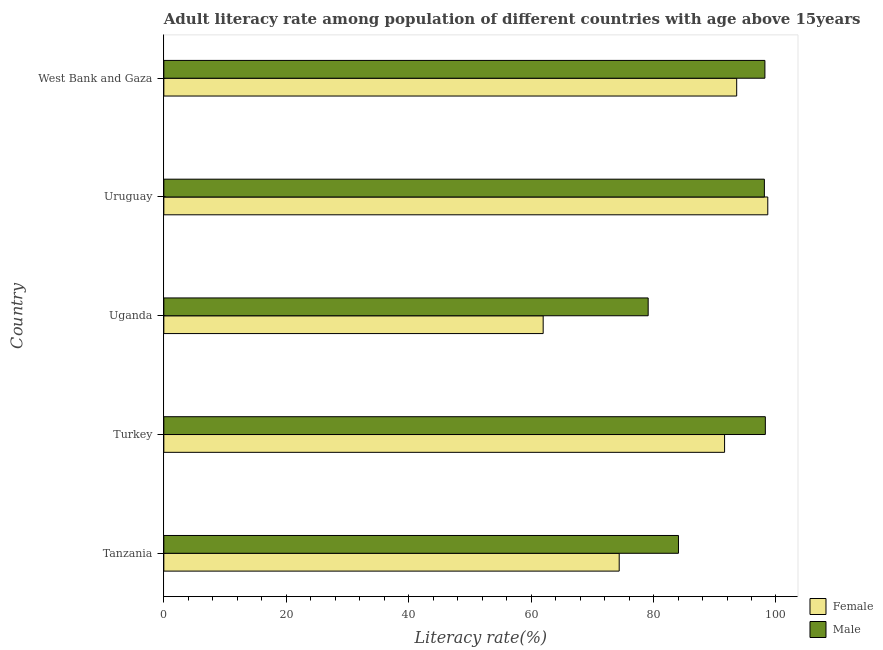How many different coloured bars are there?
Provide a short and direct response. 2. Are the number of bars per tick equal to the number of legend labels?
Provide a short and direct response. Yes. Are the number of bars on each tick of the Y-axis equal?
Offer a very short reply. Yes. What is the label of the 3rd group of bars from the top?
Your answer should be very brief. Uganda. In how many cases, is the number of bars for a given country not equal to the number of legend labels?
Keep it short and to the point. 0. What is the male adult literacy rate in Turkey?
Your answer should be very brief. 98.26. Across all countries, what is the maximum female adult literacy rate?
Provide a short and direct response. 98.66. Across all countries, what is the minimum male adult literacy rate?
Provide a short and direct response. 79.12. In which country was the male adult literacy rate minimum?
Give a very brief answer. Uganda. What is the total female adult literacy rate in the graph?
Your answer should be compact. 420.2. What is the difference between the male adult literacy rate in Tanzania and that in Uganda?
Your answer should be compact. 4.95. What is the difference between the female adult literacy rate in Turkey and the male adult literacy rate in Uruguay?
Give a very brief answer. -6.5. What is the average male adult literacy rate per country?
Make the answer very short. 91.55. What is the difference between the female adult literacy rate and male adult literacy rate in Uganda?
Your response must be concise. -17.15. In how many countries, is the male adult literacy rate greater than 8 %?
Your answer should be very brief. 5. What is the ratio of the male adult literacy rate in Tanzania to that in Turkey?
Provide a short and direct response. 0.86. What is the difference between the highest and the second highest female adult literacy rate?
Give a very brief answer. 5.08. What is the difference between the highest and the lowest female adult literacy rate?
Ensure brevity in your answer.  36.69. In how many countries, is the male adult literacy rate greater than the average male adult literacy rate taken over all countries?
Offer a very short reply. 3. What does the 1st bar from the bottom in Uganda represents?
Give a very brief answer. Female. How many bars are there?
Ensure brevity in your answer.  10. Are all the bars in the graph horizontal?
Your response must be concise. Yes. How many countries are there in the graph?
Your answer should be compact. 5. What is the difference between two consecutive major ticks on the X-axis?
Your answer should be compact. 20. Are the values on the major ticks of X-axis written in scientific E-notation?
Ensure brevity in your answer.  No. Does the graph contain any zero values?
Your response must be concise. No. Does the graph contain grids?
Make the answer very short. No. How many legend labels are there?
Provide a short and direct response. 2. What is the title of the graph?
Offer a terse response. Adult literacy rate among population of different countries with age above 15years. Does "Investment in Transport" appear as one of the legend labels in the graph?
Provide a short and direct response. No. What is the label or title of the X-axis?
Offer a terse response. Literacy rate(%). What is the Literacy rate(%) of Female in Tanzania?
Ensure brevity in your answer.  74.39. What is the Literacy rate(%) in Male in Tanzania?
Provide a succinct answer. 84.07. What is the Literacy rate(%) of Female in Turkey?
Your response must be concise. 91.6. What is the Literacy rate(%) in Male in Turkey?
Offer a terse response. 98.26. What is the Literacy rate(%) in Female in Uganda?
Your answer should be very brief. 61.97. What is the Literacy rate(%) of Male in Uganda?
Keep it short and to the point. 79.12. What is the Literacy rate(%) of Female in Uruguay?
Your answer should be very brief. 98.66. What is the Literacy rate(%) of Male in Uruguay?
Give a very brief answer. 98.1. What is the Literacy rate(%) of Female in West Bank and Gaza?
Your answer should be compact. 93.58. What is the Literacy rate(%) in Male in West Bank and Gaza?
Offer a terse response. 98.19. Across all countries, what is the maximum Literacy rate(%) of Female?
Ensure brevity in your answer.  98.66. Across all countries, what is the maximum Literacy rate(%) in Male?
Give a very brief answer. 98.26. Across all countries, what is the minimum Literacy rate(%) in Female?
Make the answer very short. 61.97. Across all countries, what is the minimum Literacy rate(%) of Male?
Provide a succinct answer. 79.12. What is the total Literacy rate(%) of Female in the graph?
Offer a terse response. 420.2. What is the total Literacy rate(%) in Male in the graph?
Offer a very short reply. 457.75. What is the difference between the Literacy rate(%) in Female in Tanzania and that in Turkey?
Offer a terse response. -17.22. What is the difference between the Literacy rate(%) of Male in Tanzania and that in Turkey?
Make the answer very short. -14.19. What is the difference between the Literacy rate(%) of Female in Tanzania and that in Uganda?
Your response must be concise. 12.42. What is the difference between the Literacy rate(%) in Male in Tanzania and that in Uganda?
Provide a succinct answer. 4.95. What is the difference between the Literacy rate(%) in Female in Tanzania and that in Uruguay?
Your answer should be very brief. -24.27. What is the difference between the Literacy rate(%) of Male in Tanzania and that in Uruguay?
Your answer should be very brief. -14.03. What is the difference between the Literacy rate(%) in Female in Tanzania and that in West Bank and Gaza?
Offer a very short reply. -19.19. What is the difference between the Literacy rate(%) of Male in Tanzania and that in West Bank and Gaza?
Your answer should be compact. -14.12. What is the difference between the Literacy rate(%) of Female in Turkey and that in Uganda?
Provide a succinct answer. 29.63. What is the difference between the Literacy rate(%) in Male in Turkey and that in Uganda?
Give a very brief answer. 19.14. What is the difference between the Literacy rate(%) in Female in Turkey and that in Uruguay?
Give a very brief answer. -7.06. What is the difference between the Literacy rate(%) in Male in Turkey and that in Uruguay?
Give a very brief answer. 0.16. What is the difference between the Literacy rate(%) of Female in Turkey and that in West Bank and Gaza?
Offer a very short reply. -1.98. What is the difference between the Literacy rate(%) in Male in Turkey and that in West Bank and Gaza?
Make the answer very short. 0.07. What is the difference between the Literacy rate(%) of Female in Uganda and that in Uruguay?
Provide a succinct answer. -36.69. What is the difference between the Literacy rate(%) in Male in Uganda and that in Uruguay?
Make the answer very short. -18.98. What is the difference between the Literacy rate(%) of Female in Uganda and that in West Bank and Gaza?
Provide a short and direct response. -31.61. What is the difference between the Literacy rate(%) of Male in Uganda and that in West Bank and Gaza?
Provide a short and direct response. -19.07. What is the difference between the Literacy rate(%) of Female in Uruguay and that in West Bank and Gaza?
Offer a terse response. 5.08. What is the difference between the Literacy rate(%) of Male in Uruguay and that in West Bank and Gaza?
Keep it short and to the point. -0.09. What is the difference between the Literacy rate(%) of Female in Tanzania and the Literacy rate(%) of Male in Turkey?
Offer a terse response. -23.87. What is the difference between the Literacy rate(%) in Female in Tanzania and the Literacy rate(%) in Male in Uganda?
Give a very brief answer. -4.73. What is the difference between the Literacy rate(%) in Female in Tanzania and the Literacy rate(%) in Male in Uruguay?
Provide a short and direct response. -23.72. What is the difference between the Literacy rate(%) of Female in Tanzania and the Literacy rate(%) of Male in West Bank and Gaza?
Offer a very short reply. -23.8. What is the difference between the Literacy rate(%) of Female in Turkey and the Literacy rate(%) of Male in Uganda?
Keep it short and to the point. 12.48. What is the difference between the Literacy rate(%) in Female in Turkey and the Literacy rate(%) in Male in Uruguay?
Make the answer very short. -6.5. What is the difference between the Literacy rate(%) of Female in Turkey and the Literacy rate(%) of Male in West Bank and Gaza?
Keep it short and to the point. -6.59. What is the difference between the Literacy rate(%) of Female in Uganda and the Literacy rate(%) of Male in Uruguay?
Your answer should be very brief. -36.13. What is the difference between the Literacy rate(%) in Female in Uganda and the Literacy rate(%) in Male in West Bank and Gaza?
Your answer should be very brief. -36.22. What is the difference between the Literacy rate(%) of Female in Uruguay and the Literacy rate(%) of Male in West Bank and Gaza?
Your answer should be compact. 0.47. What is the average Literacy rate(%) in Female per country?
Keep it short and to the point. 84.04. What is the average Literacy rate(%) of Male per country?
Ensure brevity in your answer.  91.55. What is the difference between the Literacy rate(%) in Female and Literacy rate(%) in Male in Tanzania?
Offer a very short reply. -9.68. What is the difference between the Literacy rate(%) in Female and Literacy rate(%) in Male in Turkey?
Provide a succinct answer. -6.66. What is the difference between the Literacy rate(%) of Female and Literacy rate(%) of Male in Uganda?
Your answer should be very brief. -17.15. What is the difference between the Literacy rate(%) of Female and Literacy rate(%) of Male in Uruguay?
Your answer should be compact. 0.56. What is the difference between the Literacy rate(%) in Female and Literacy rate(%) in Male in West Bank and Gaza?
Your answer should be very brief. -4.61. What is the ratio of the Literacy rate(%) in Female in Tanzania to that in Turkey?
Give a very brief answer. 0.81. What is the ratio of the Literacy rate(%) of Male in Tanzania to that in Turkey?
Offer a very short reply. 0.86. What is the ratio of the Literacy rate(%) of Female in Tanzania to that in Uganda?
Provide a succinct answer. 1.2. What is the ratio of the Literacy rate(%) in Female in Tanzania to that in Uruguay?
Keep it short and to the point. 0.75. What is the ratio of the Literacy rate(%) in Male in Tanzania to that in Uruguay?
Give a very brief answer. 0.86. What is the ratio of the Literacy rate(%) in Female in Tanzania to that in West Bank and Gaza?
Your response must be concise. 0.79. What is the ratio of the Literacy rate(%) of Male in Tanzania to that in West Bank and Gaza?
Ensure brevity in your answer.  0.86. What is the ratio of the Literacy rate(%) in Female in Turkey to that in Uganda?
Your answer should be very brief. 1.48. What is the ratio of the Literacy rate(%) of Male in Turkey to that in Uganda?
Your answer should be very brief. 1.24. What is the ratio of the Literacy rate(%) in Female in Turkey to that in Uruguay?
Give a very brief answer. 0.93. What is the ratio of the Literacy rate(%) in Male in Turkey to that in Uruguay?
Your response must be concise. 1. What is the ratio of the Literacy rate(%) of Female in Turkey to that in West Bank and Gaza?
Your response must be concise. 0.98. What is the ratio of the Literacy rate(%) in Female in Uganda to that in Uruguay?
Give a very brief answer. 0.63. What is the ratio of the Literacy rate(%) of Male in Uganda to that in Uruguay?
Keep it short and to the point. 0.81. What is the ratio of the Literacy rate(%) in Female in Uganda to that in West Bank and Gaza?
Offer a terse response. 0.66. What is the ratio of the Literacy rate(%) in Male in Uganda to that in West Bank and Gaza?
Provide a short and direct response. 0.81. What is the ratio of the Literacy rate(%) of Female in Uruguay to that in West Bank and Gaza?
Provide a short and direct response. 1.05. What is the ratio of the Literacy rate(%) of Male in Uruguay to that in West Bank and Gaza?
Provide a short and direct response. 1. What is the difference between the highest and the second highest Literacy rate(%) in Female?
Make the answer very short. 5.08. What is the difference between the highest and the second highest Literacy rate(%) in Male?
Offer a terse response. 0.07. What is the difference between the highest and the lowest Literacy rate(%) of Female?
Ensure brevity in your answer.  36.69. What is the difference between the highest and the lowest Literacy rate(%) of Male?
Offer a terse response. 19.14. 